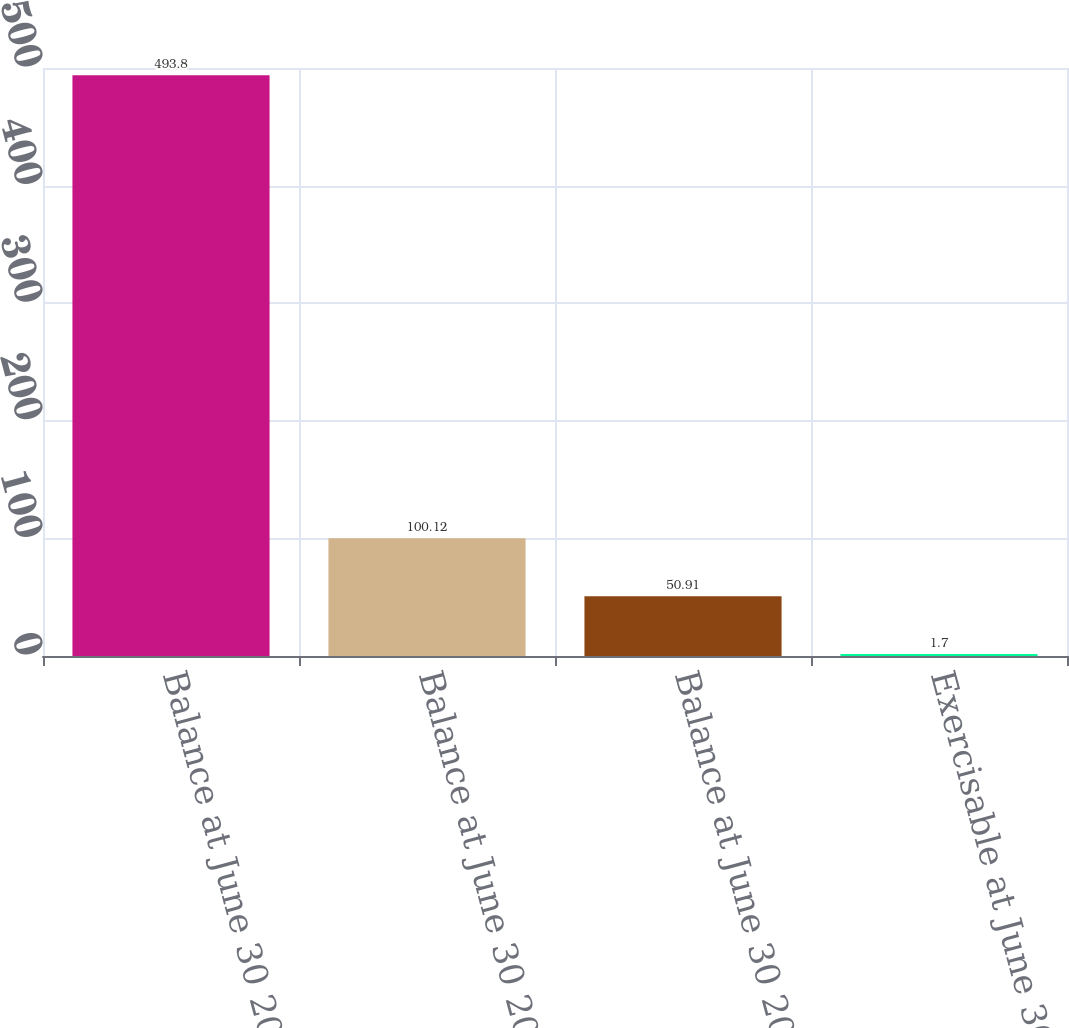Convert chart. <chart><loc_0><loc_0><loc_500><loc_500><bar_chart><fcel>Balance at June 30 2007<fcel>Balance at June 30 2008<fcel>Balance at June 30 2009<fcel>Exercisable at June 30 2009<nl><fcel>493.8<fcel>100.12<fcel>50.91<fcel>1.7<nl></chart> 